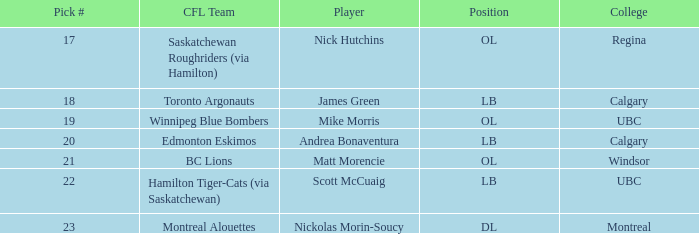Which player is on the BC Lions?  Matt Morencie. 